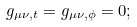<formula> <loc_0><loc_0><loc_500><loc_500>g _ { \mu \nu , t } = g _ { \mu \nu , \phi } = 0 ;</formula> 